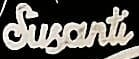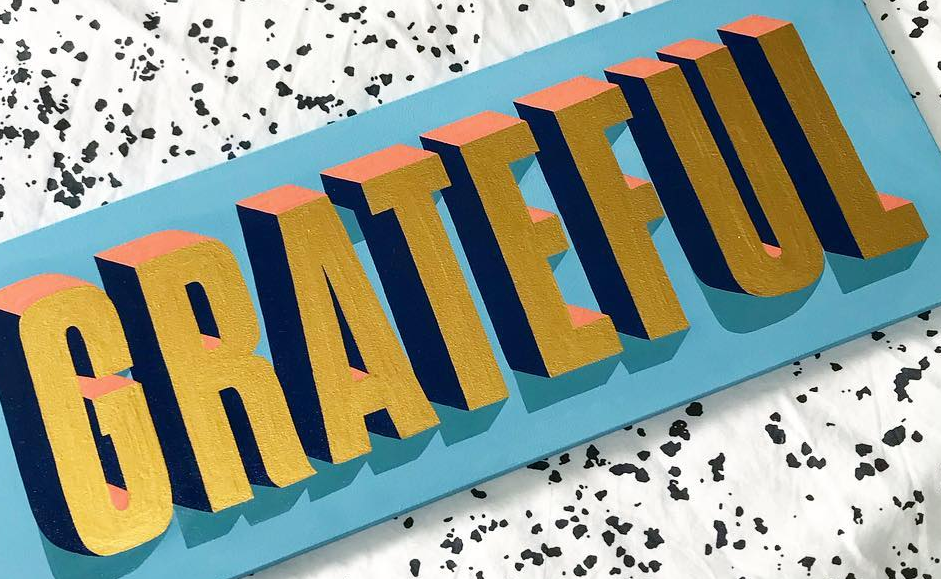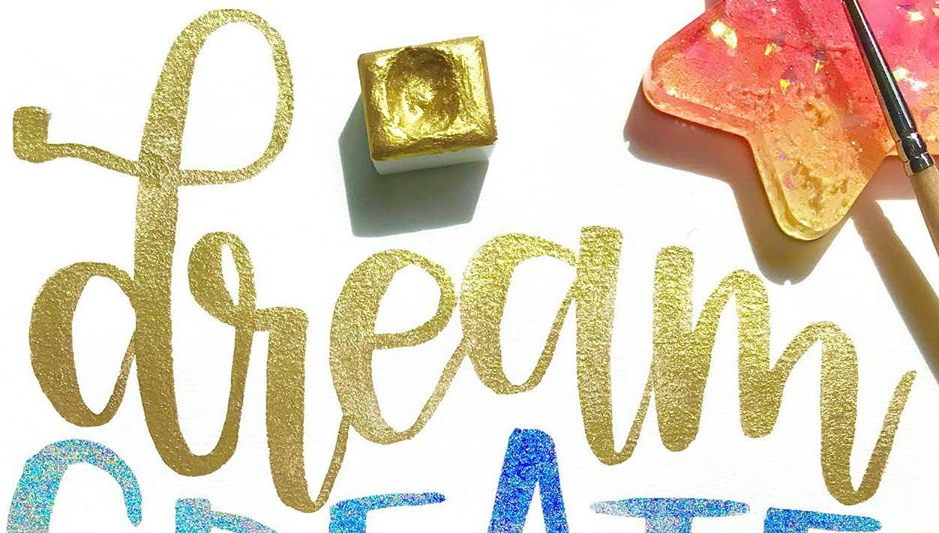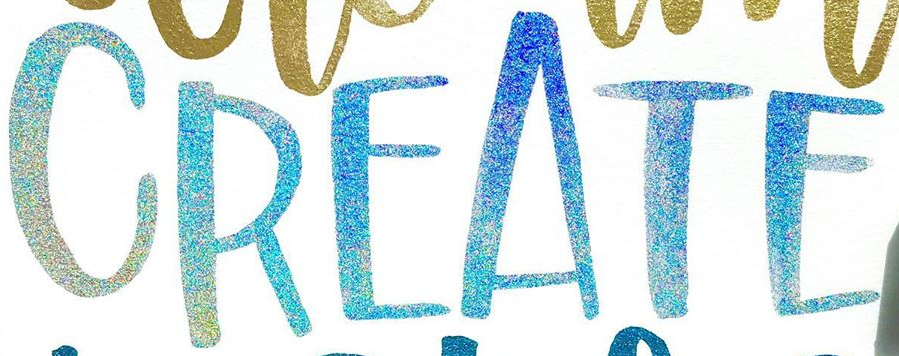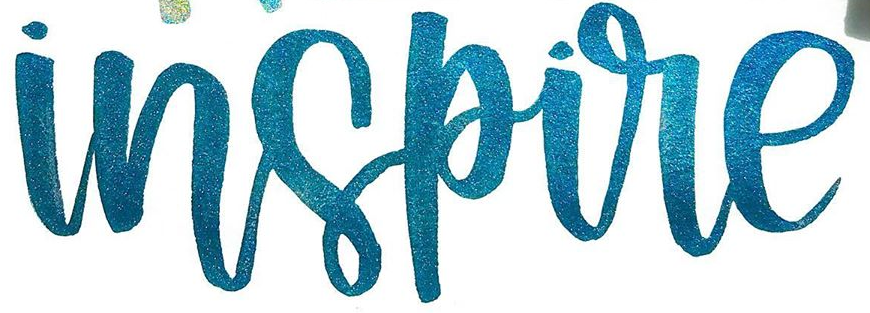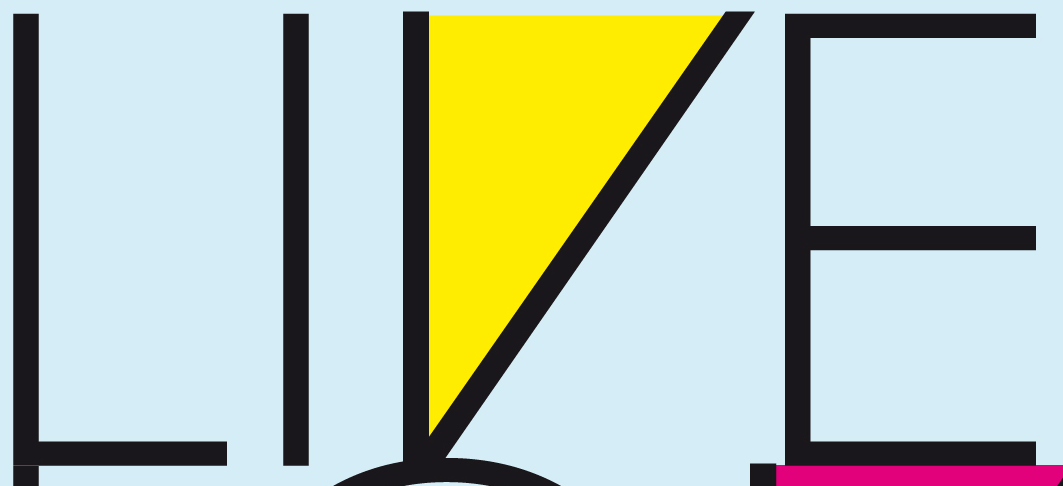What words are shown in these images in order, separated by a semicolon? Susanti; GRATEFUL; dream; CREATE; inspire; LIVE 